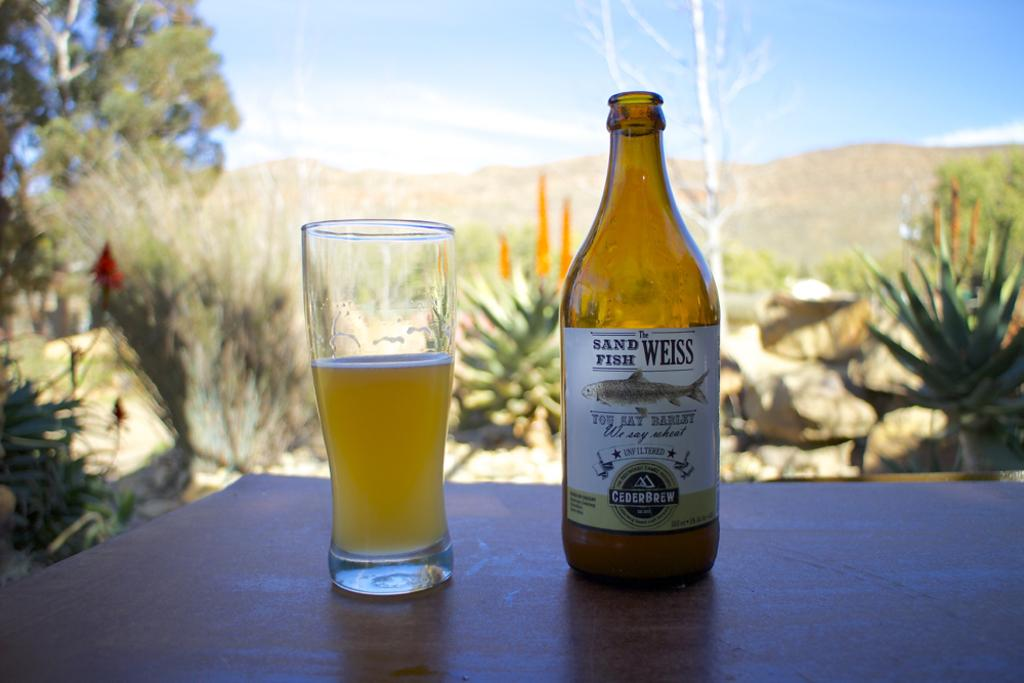<image>
Give a short and clear explanation of the subsequent image. Sand Fish Weiss beer bottle next to a half filled glass of beer. 